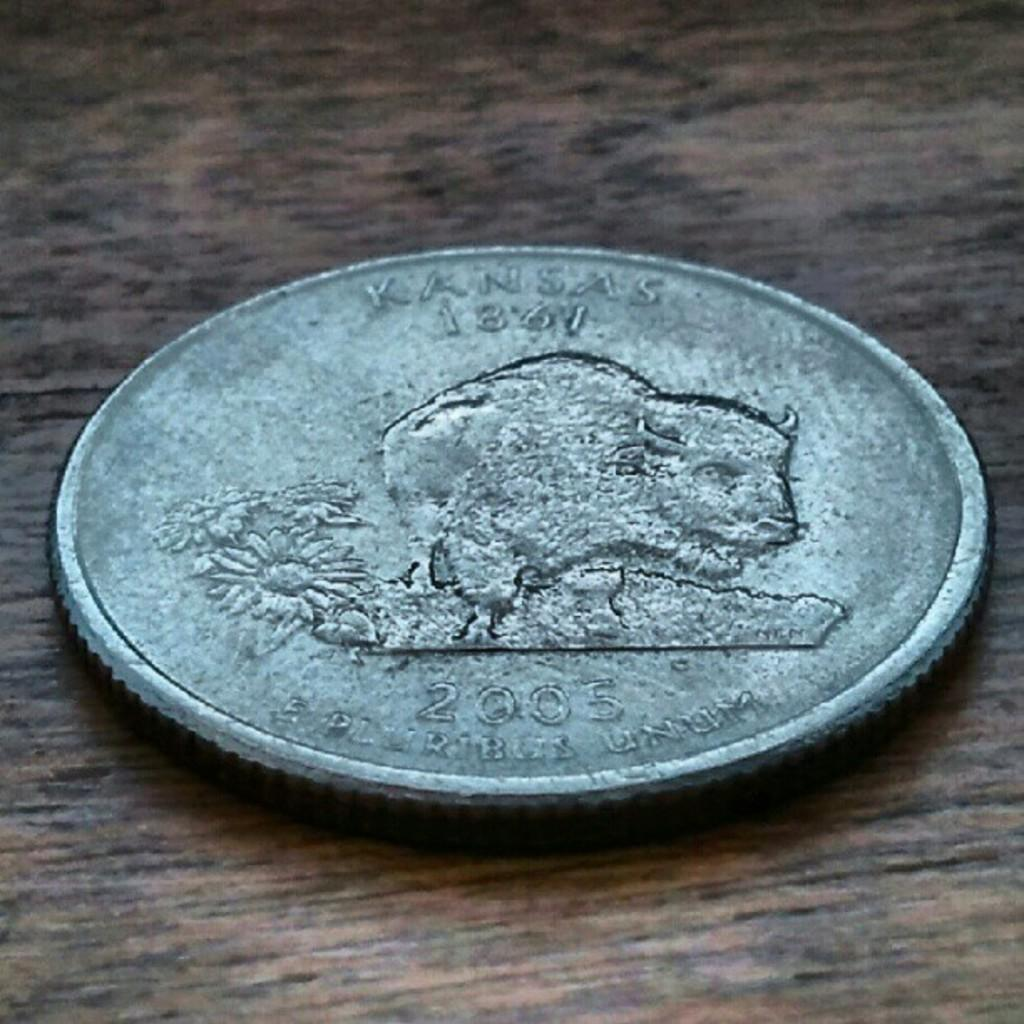Provide a one-sentence caption for the provided image. a tarnished silver coin with the word Kansas on the top. 